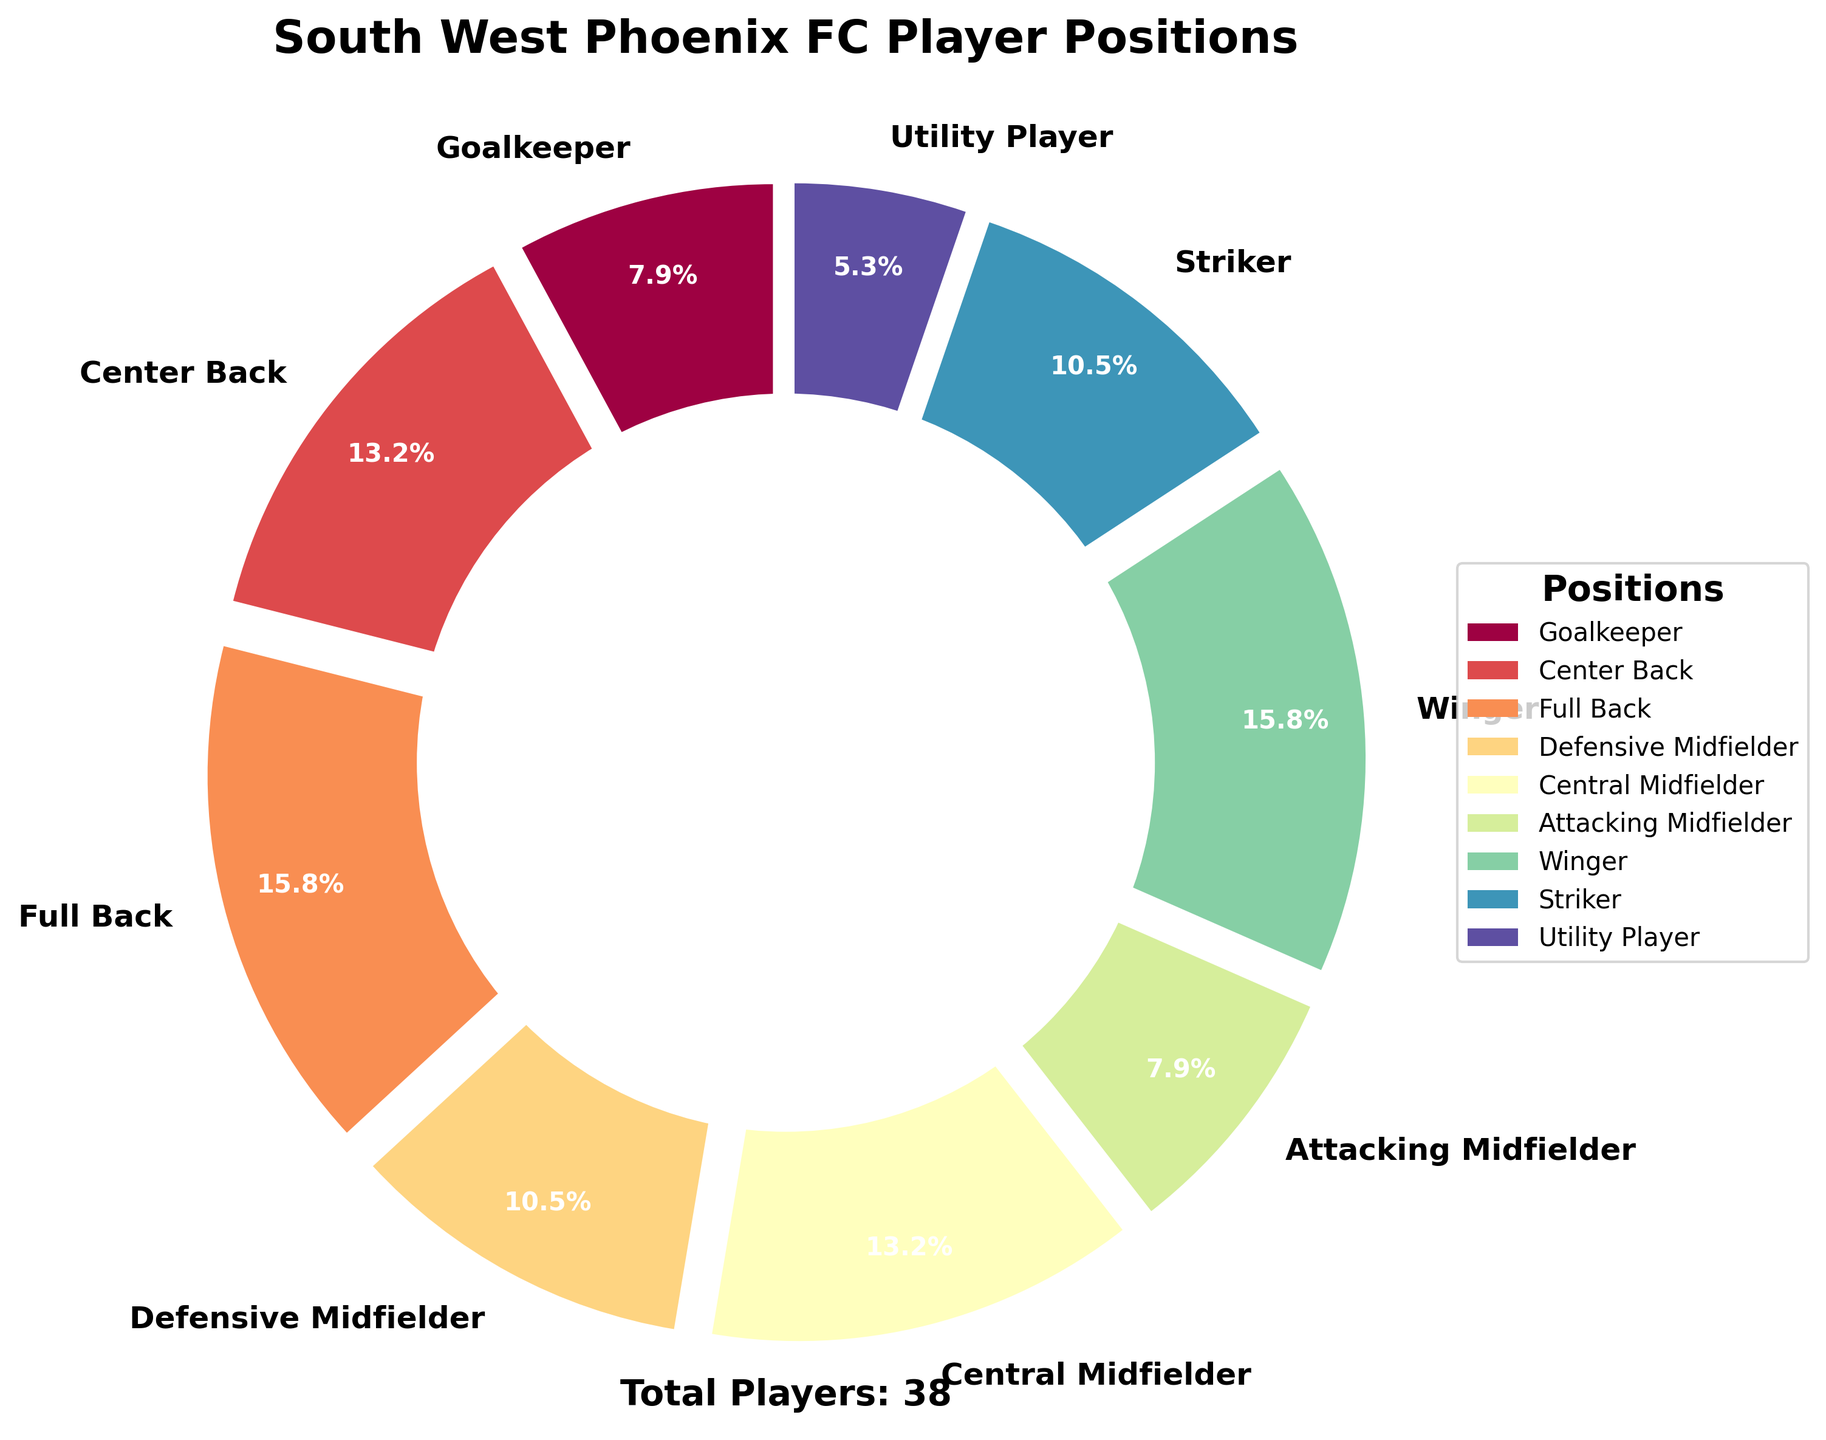What's the distribution percentage for the Full Back position? The pie chart is divided into sections that represent each player position with their corresponding percentage. The Full Back position shows a specific percentage on the chart.
Answer: 17.7% Which position has the highest number of players? By looking at the pie chart, the largest section indicates the position with the highest count of players.
Answer: Full Back and Winger How many players are classified as Utility Players? The pie chart includes a section for Utility Players, and the text label on that section indicates the count.
Answer: 2 What's the total number of players in the South West Phoenix FC squad? The total number of players is provided at the bottom of the pie chart.
Answer: 38 What is the position with the least number of players? The smallest wedge of the pie chart represents the position with the least number of players.
Answer: Utility Player How many players are either Goalkeepers or Attacking Midfielders? Add the counts for Goalkeepers and Attacking Midfielders from the chart. Goalkeepers: 3, Attacking Midfielders: 3. So, the total is 3 + 3.
Answer: 6 Compare the number of Central Midfielders to Strikers. Which position has more players? By looking at the chart, find the sections for Central Midfielders and Strikers and compare their counts. Central Midfielders: 5, Strikers: 4.
Answer: Central Midfielder What is the combined percentage of players who are either Wingers or Strikers? Add the percentages shown on the pie chart for Wingers and Strikers. Wingers: 17.7%, Strikers: 11.8%. So, the combined percentage is 17.7% + 11.8%.
Answer: 29.5% What's the difference in the number of players between Center Backs and Defensive Midfielders? Subtract the count for Defensive Midfielders from the count for Center Backs. Center Backs: 5, Defensive Midfielders: 4. So, the difference is 5 - 4.
Answer: 1 What colors are used for the Winger position in the pie chart? Visually identify the color used for the Winger section by looking at the corresponding part of the pie chart.
Answer: It varies based on the colormap, but can be described as a specific shade present in the chart 